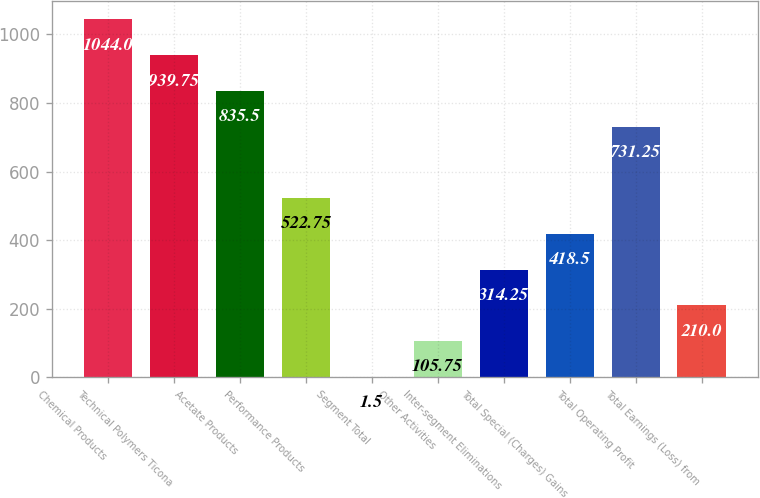Convert chart. <chart><loc_0><loc_0><loc_500><loc_500><bar_chart><fcel>Chemical Products<fcel>Technical Polymers Ticona<fcel>Acetate Products<fcel>Performance Products<fcel>Segment Total<fcel>Other Activities<fcel>Inter-segment Eliminations<fcel>Total Special (Charges) Gains<fcel>Total Operating Profit<fcel>Total Earnings (Loss) from<nl><fcel>1044<fcel>939.75<fcel>835.5<fcel>522.75<fcel>1.5<fcel>105.75<fcel>314.25<fcel>418.5<fcel>731.25<fcel>210<nl></chart> 